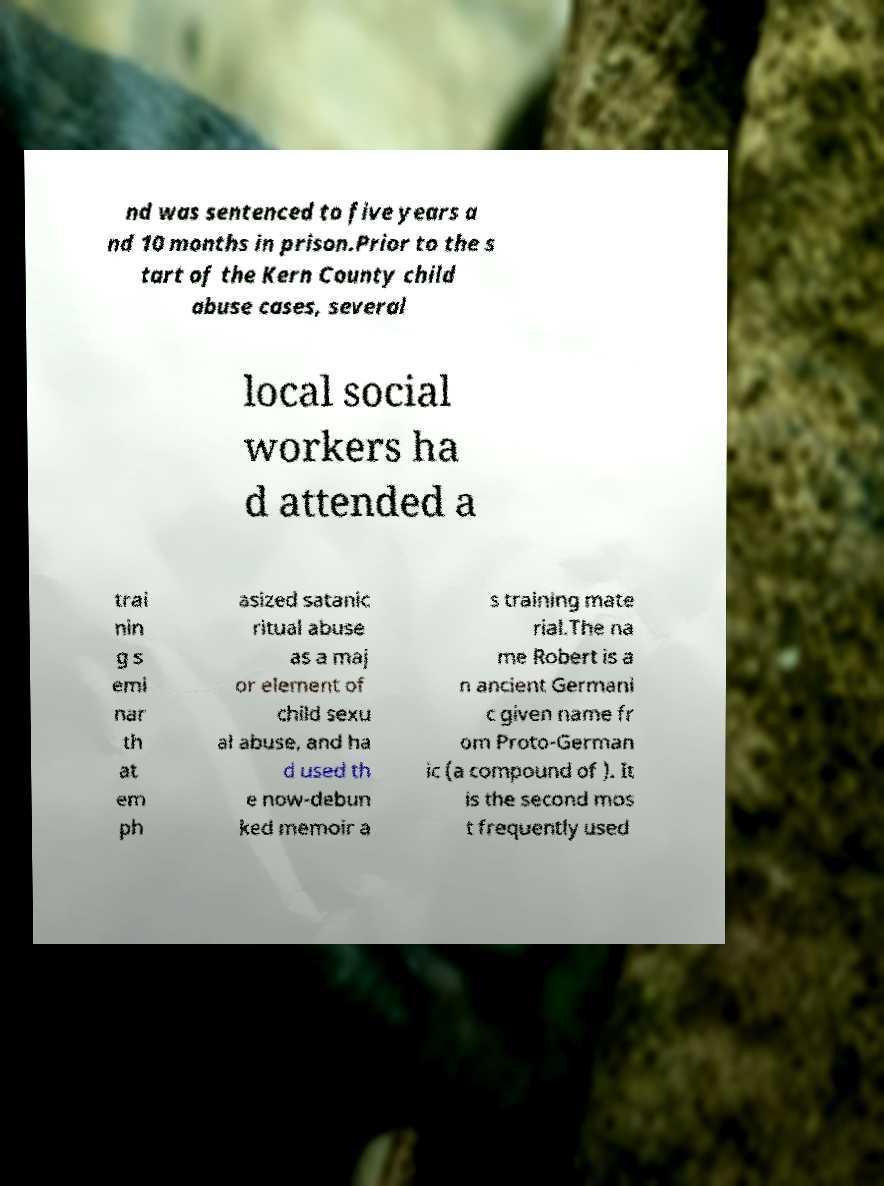What messages or text are displayed in this image? I need them in a readable, typed format. nd was sentenced to five years a nd 10 months in prison.Prior to the s tart of the Kern County child abuse cases, several local social workers ha d attended a trai nin g s emi nar th at em ph asized satanic ritual abuse as a maj or element of child sexu al abuse, and ha d used th e now-debun ked memoir a s training mate rial.The na me Robert is a n ancient Germani c given name fr om Proto-German ic (a compound of ). It is the second mos t frequently used 